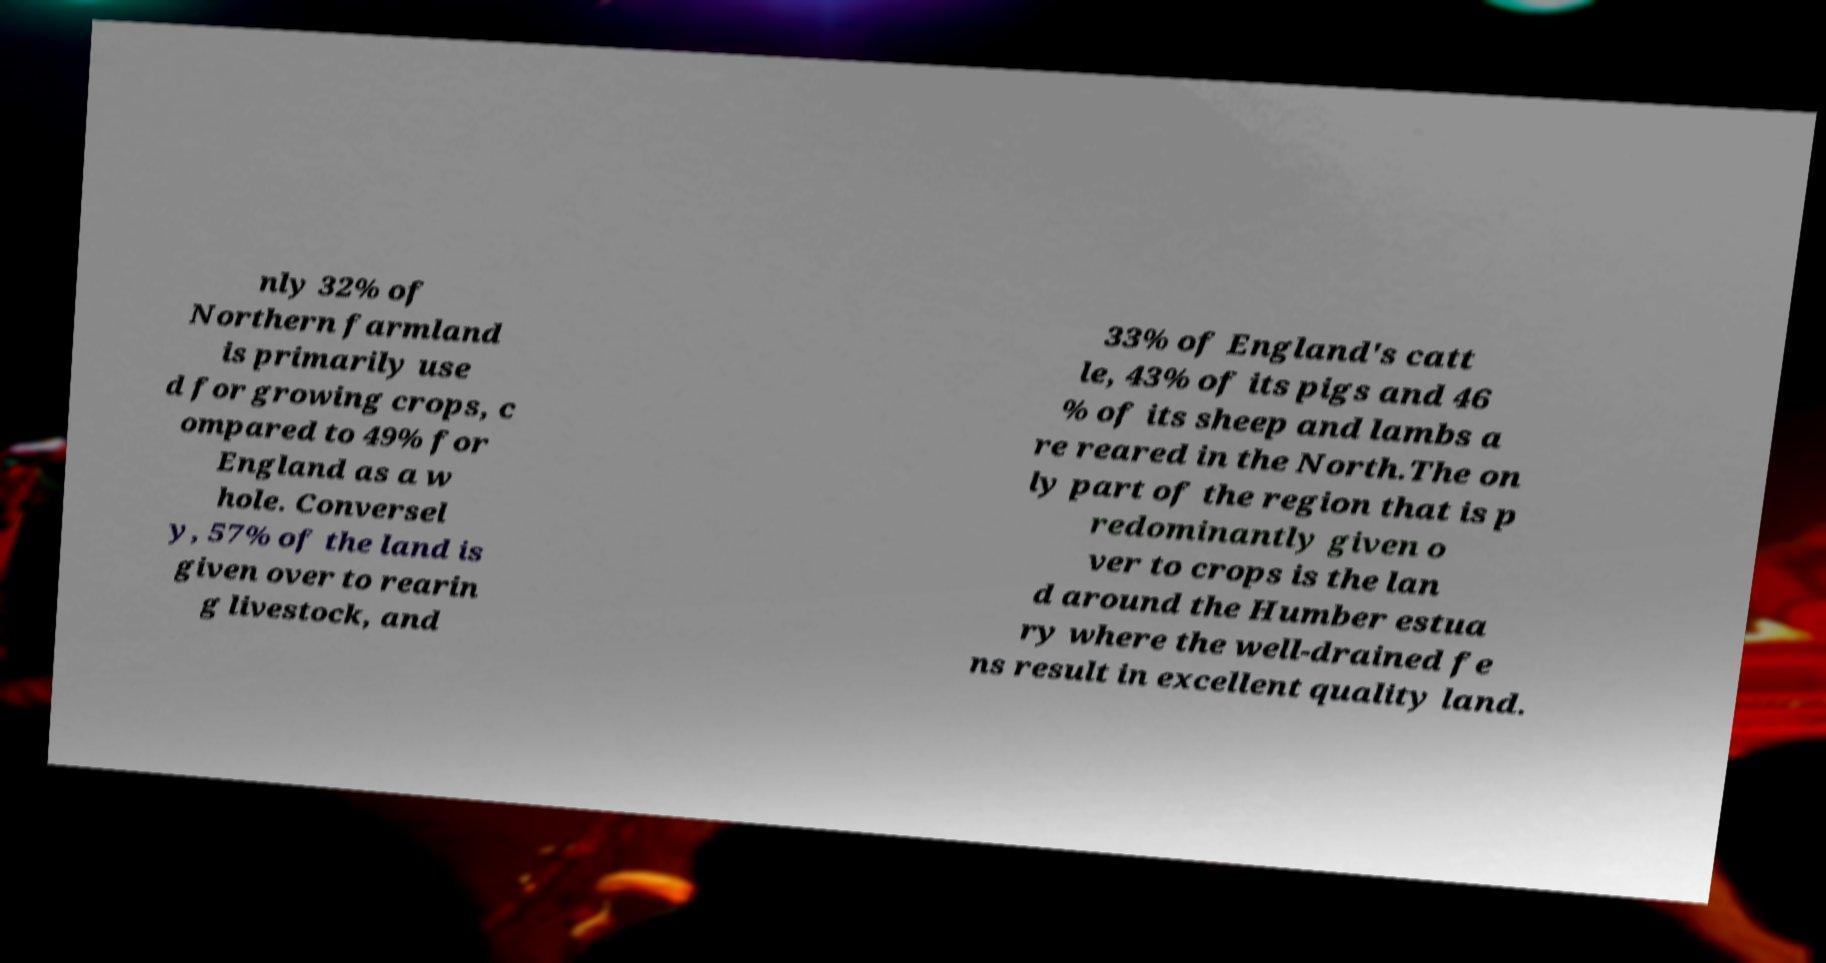Please identify and transcribe the text found in this image. nly 32% of Northern farmland is primarily use d for growing crops, c ompared to 49% for England as a w hole. Conversel y, 57% of the land is given over to rearin g livestock, and 33% of England's catt le, 43% of its pigs and 46 % of its sheep and lambs a re reared in the North.The on ly part of the region that is p redominantly given o ver to crops is the lan d around the Humber estua ry where the well-drained fe ns result in excellent quality land. 